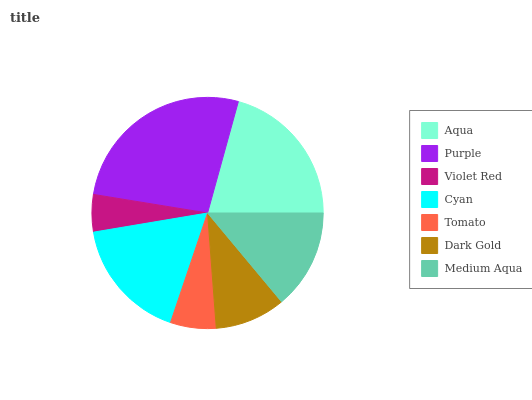Is Violet Red the minimum?
Answer yes or no. Yes. Is Purple the maximum?
Answer yes or no. Yes. Is Purple the minimum?
Answer yes or no. No. Is Violet Red the maximum?
Answer yes or no. No. Is Purple greater than Violet Red?
Answer yes or no. Yes. Is Violet Red less than Purple?
Answer yes or no. Yes. Is Violet Red greater than Purple?
Answer yes or no. No. Is Purple less than Violet Red?
Answer yes or no. No. Is Medium Aqua the high median?
Answer yes or no. Yes. Is Medium Aqua the low median?
Answer yes or no. Yes. Is Dark Gold the high median?
Answer yes or no. No. Is Violet Red the low median?
Answer yes or no. No. 